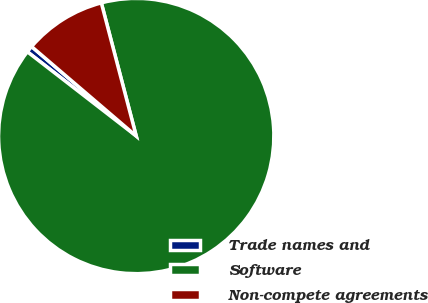<chart> <loc_0><loc_0><loc_500><loc_500><pie_chart><fcel>Trade names and<fcel>Software<fcel>Non-compete agreements<nl><fcel>0.78%<fcel>89.56%<fcel>9.66%<nl></chart> 